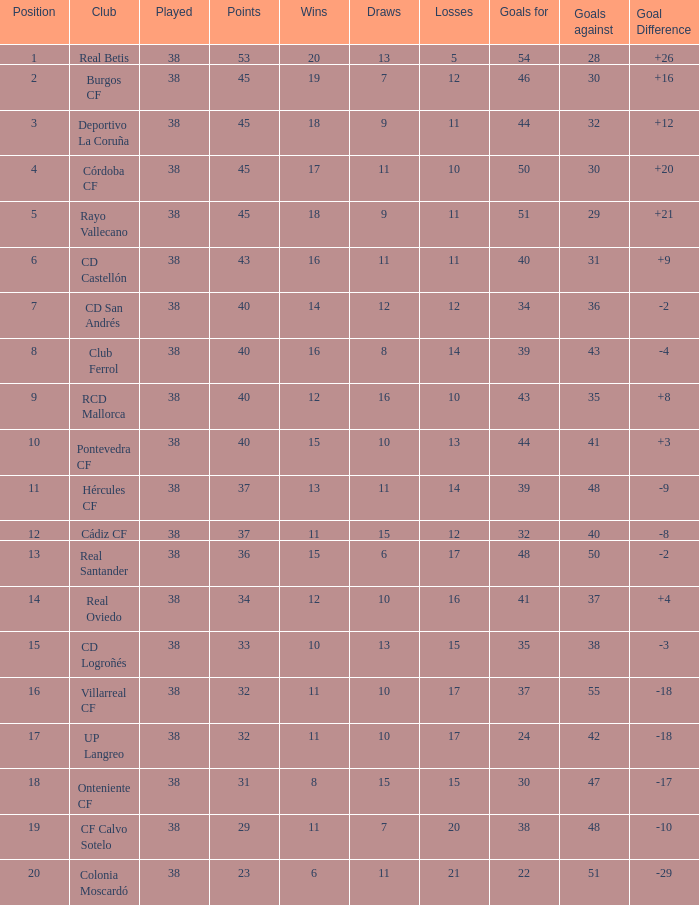What is the maximum goals against when the club is "pontevedra cf" and played is fewer than 38? None. 